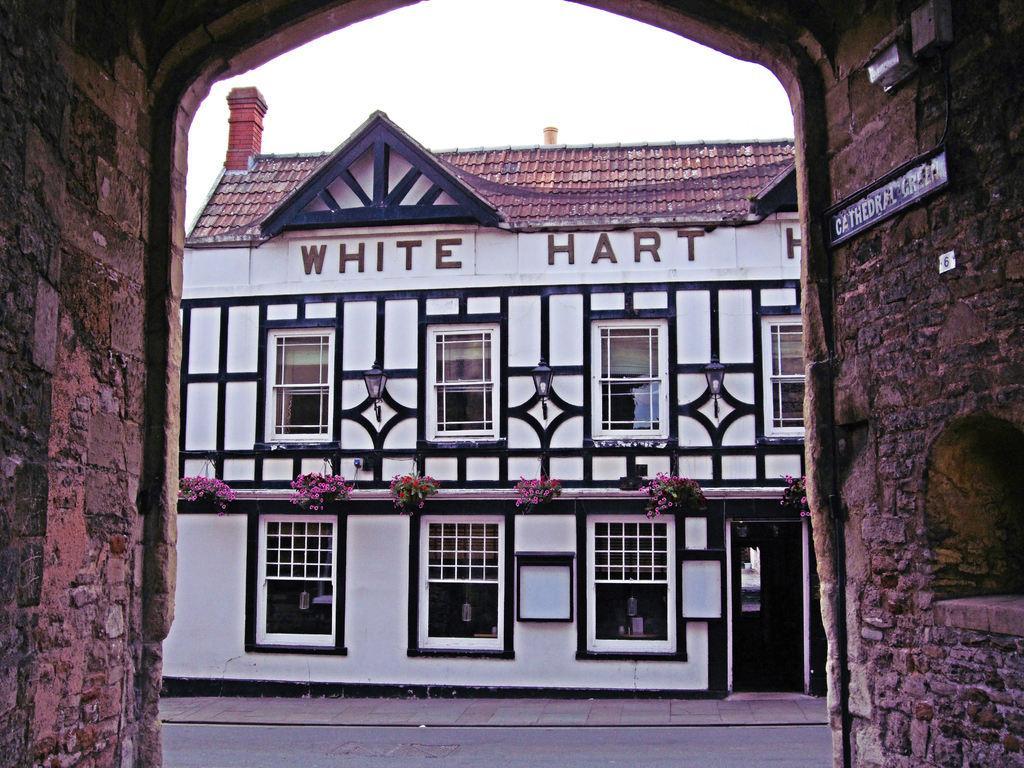Describe this image in one or two sentences. On the right it is a brick wall, on the wall there is a board. On the left it is well. In the center of the picture we can see a building, on the building there are flowers, text. In the foreground we can see road and footpath. At the top it is sky. 